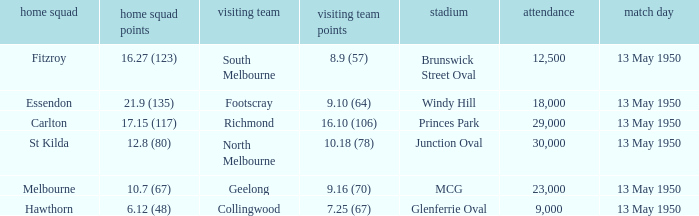What was the lowest crowd size at the Windy Hill venue? 18000.0. 